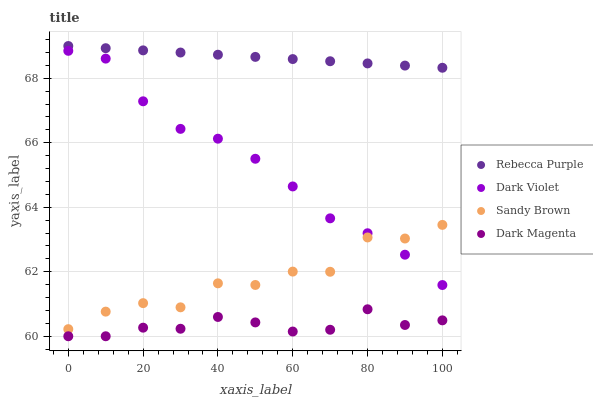Does Dark Magenta have the minimum area under the curve?
Answer yes or no. Yes. Does Rebecca Purple have the maximum area under the curve?
Answer yes or no. Yes. Does Dark Violet have the minimum area under the curve?
Answer yes or no. No. Does Dark Violet have the maximum area under the curve?
Answer yes or no. No. Is Rebecca Purple the smoothest?
Answer yes or no. Yes. Is Sandy Brown the roughest?
Answer yes or no. Yes. Is Dark Violet the smoothest?
Answer yes or no. No. Is Dark Violet the roughest?
Answer yes or no. No. Does Dark Magenta have the lowest value?
Answer yes or no. Yes. Does Dark Violet have the lowest value?
Answer yes or no. No. Does Rebecca Purple have the highest value?
Answer yes or no. Yes. Does Dark Violet have the highest value?
Answer yes or no. No. Is Sandy Brown less than Rebecca Purple?
Answer yes or no. Yes. Is Rebecca Purple greater than Dark Violet?
Answer yes or no. Yes. Does Sandy Brown intersect Dark Violet?
Answer yes or no. Yes. Is Sandy Brown less than Dark Violet?
Answer yes or no. No. Is Sandy Brown greater than Dark Violet?
Answer yes or no. No. Does Sandy Brown intersect Rebecca Purple?
Answer yes or no. No. 